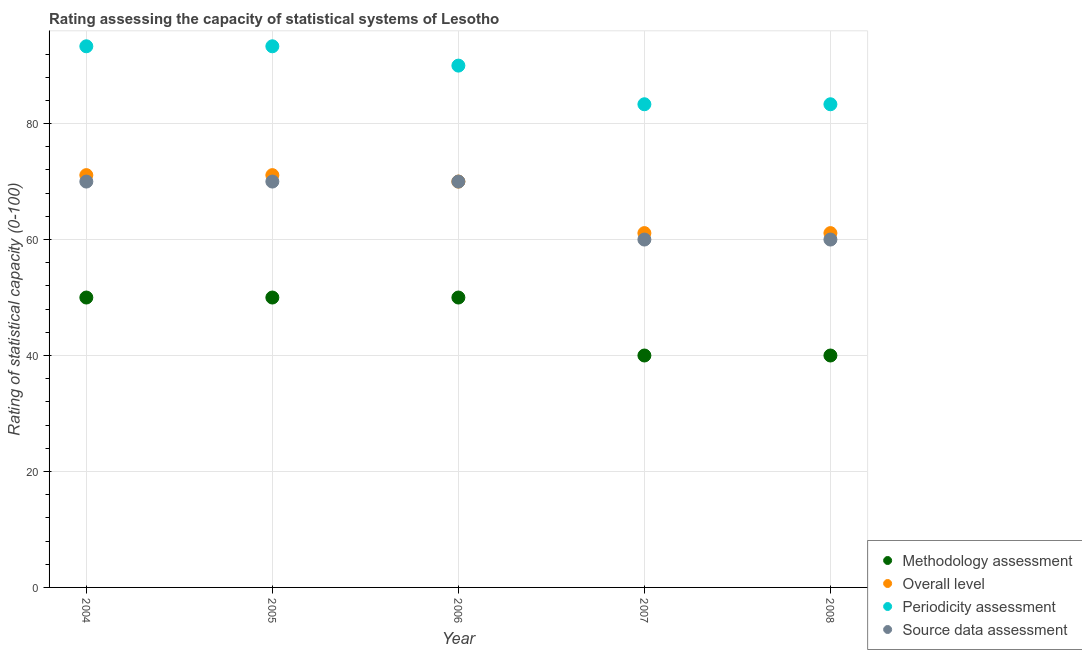Is the number of dotlines equal to the number of legend labels?
Provide a succinct answer. Yes. What is the source data assessment rating in 2008?
Your response must be concise. 60. Across all years, what is the maximum overall level rating?
Make the answer very short. 71.11. Across all years, what is the minimum source data assessment rating?
Your answer should be very brief. 60. In which year was the source data assessment rating maximum?
Make the answer very short. 2004. What is the total overall level rating in the graph?
Make the answer very short. 334.44. What is the difference between the periodicity assessment rating in 2004 and that in 2006?
Provide a short and direct response. 3.33. What is the difference between the methodology assessment rating in 2006 and the source data assessment rating in 2008?
Offer a terse response. -10. What is the average source data assessment rating per year?
Ensure brevity in your answer.  66. In the year 2006, what is the difference between the methodology assessment rating and source data assessment rating?
Ensure brevity in your answer.  -20. In how many years, is the periodicity assessment rating greater than 68?
Offer a very short reply. 5. What is the ratio of the overall level rating in 2005 to that in 2008?
Offer a very short reply. 1.16. What is the difference between the highest and the lowest methodology assessment rating?
Offer a very short reply. 10. Is the sum of the source data assessment rating in 2005 and 2008 greater than the maximum overall level rating across all years?
Your response must be concise. Yes. Is it the case that in every year, the sum of the methodology assessment rating and source data assessment rating is greater than the sum of periodicity assessment rating and overall level rating?
Your answer should be compact. No. Does the methodology assessment rating monotonically increase over the years?
Your answer should be compact. No. Is the overall level rating strictly greater than the methodology assessment rating over the years?
Give a very brief answer. Yes. Is the methodology assessment rating strictly less than the periodicity assessment rating over the years?
Offer a terse response. Yes. How many dotlines are there?
Provide a succinct answer. 4. How many legend labels are there?
Make the answer very short. 4. How are the legend labels stacked?
Your answer should be very brief. Vertical. What is the title of the graph?
Provide a succinct answer. Rating assessing the capacity of statistical systems of Lesotho. Does "Japan" appear as one of the legend labels in the graph?
Ensure brevity in your answer.  No. What is the label or title of the X-axis?
Your answer should be compact. Year. What is the label or title of the Y-axis?
Offer a terse response. Rating of statistical capacity (0-100). What is the Rating of statistical capacity (0-100) of Methodology assessment in 2004?
Keep it short and to the point. 50. What is the Rating of statistical capacity (0-100) in Overall level in 2004?
Your response must be concise. 71.11. What is the Rating of statistical capacity (0-100) of Periodicity assessment in 2004?
Provide a succinct answer. 93.33. What is the Rating of statistical capacity (0-100) in Overall level in 2005?
Your answer should be very brief. 71.11. What is the Rating of statistical capacity (0-100) in Periodicity assessment in 2005?
Your answer should be compact. 93.33. What is the Rating of statistical capacity (0-100) of Source data assessment in 2005?
Your answer should be very brief. 70. What is the Rating of statistical capacity (0-100) in Methodology assessment in 2006?
Give a very brief answer. 50. What is the Rating of statistical capacity (0-100) of Source data assessment in 2006?
Offer a terse response. 70. What is the Rating of statistical capacity (0-100) in Overall level in 2007?
Ensure brevity in your answer.  61.11. What is the Rating of statistical capacity (0-100) of Periodicity assessment in 2007?
Keep it short and to the point. 83.33. What is the Rating of statistical capacity (0-100) of Source data assessment in 2007?
Ensure brevity in your answer.  60. What is the Rating of statistical capacity (0-100) in Overall level in 2008?
Your response must be concise. 61.11. What is the Rating of statistical capacity (0-100) of Periodicity assessment in 2008?
Ensure brevity in your answer.  83.33. What is the Rating of statistical capacity (0-100) of Source data assessment in 2008?
Offer a very short reply. 60. Across all years, what is the maximum Rating of statistical capacity (0-100) of Methodology assessment?
Keep it short and to the point. 50. Across all years, what is the maximum Rating of statistical capacity (0-100) of Overall level?
Offer a terse response. 71.11. Across all years, what is the maximum Rating of statistical capacity (0-100) of Periodicity assessment?
Your answer should be very brief. 93.33. Across all years, what is the minimum Rating of statistical capacity (0-100) of Methodology assessment?
Offer a terse response. 40. Across all years, what is the minimum Rating of statistical capacity (0-100) of Overall level?
Keep it short and to the point. 61.11. Across all years, what is the minimum Rating of statistical capacity (0-100) of Periodicity assessment?
Provide a succinct answer. 83.33. Across all years, what is the minimum Rating of statistical capacity (0-100) in Source data assessment?
Provide a succinct answer. 60. What is the total Rating of statistical capacity (0-100) in Methodology assessment in the graph?
Offer a very short reply. 230. What is the total Rating of statistical capacity (0-100) in Overall level in the graph?
Provide a succinct answer. 334.44. What is the total Rating of statistical capacity (0-100) of Periodicity assessment in the graph?
Your answer should be compact. 443.33. What is the total Rating of statistical capacity (0-100) of Source data assessment in the graph?
Your answer should be very brief. 330. What is the difference between the Rating of statistical capacity (0-100) of Source data assessment in 2004 and that in 2005?
Offer a very short reply. 0. What is the difference between the Rating of statistical capacity (0-100) of Periodicity assessment in 2004 and that in 2006?
Ensure brevity in your answer.  3.33. What is the difference between the Rating of statistical capacity (0-100) in Methodology assessment in 2004 and that in 2008?
Your answer should be compact. 10. What is the difference between the Rating of statistical capacity (0-100) in Overall level in 2004 and that in 2008?
Keep it short and to the point. 10. What is the difference between the Rating of statistical capacity (0-100) of Methodology assessment in 2005 and that in 2006?
Provide a short and direct response. 0. What is the difference between the Rating of statistical capacity (0-100) in Periodicity assessment in 2005 and that in 2006?
Your answer should be very brief. 3.33. What is the difference between the Rating of statistical capacity (0-100) in Methodology assessment in 2005 and that in 2007?
Provide a short and direct response. 10. What is the difference between the Rating of statistical capacity (0-100) in Periodicity assessment in 2005 and that in 2007?
Offer a very short reply. 10. What is the difference between the Rating of statistical capacity (0-100) in Source data assessment in 2005 and that in 2007?
Give a very brief answer. 10. What is the difference between the Rating of statistical capacity (0-100) of Methodology assessment in 2005 and that in 2008?
Provide a succinct answer. 10. What is the difference between the Rating of statistical capacity (0-100) of Overall level in 2005 and that in 2008?
Give a very brief answer. 10. What is the difference between the Rating of statistical capacity (0-100) in Periodicity assessment in 2005 and that in 2008?
Offer a terse response. 10. What is the difference between the Rating of statistical capacity (0-100) of Methodology assessment in 2006 and that in 2007?
Your response must be concise. 10. What is the difference between the Rating of statistical capacity (0-100) in Overall level in 2006 and that in 2007?
Your answer should be compact. 8.89. What is the difference between the Rating of statistical capacity (0-100) of Source data assessment in 2006 and that in 2007?
Ensure brevity in your answer.  10. What is the difference between the Rating of statistical capacity (0-100) of Overall level in 2006 and that in 2008?
Ensure brevity in your answer.  8.89. What is the difference between the Rating of statistical capacity (0-100) of Periodicity assessment in 2006 and that in 2008?
Provide a short and direct response. 6.67. What is the difference between the Rating of statistical capacity (0-100) of Methodology assessment in 2007 and that in 2008?
Your response must be concise. 0. What is the difference between the Rating of statistical capacity (0-100) in Periodicity assessment in 2007 and that in 2008?
Make the answer very short. 0. What is the difference between the Rating of statistical capacity (0-100) of Methodology assessment in 2004 and the Rating of statistical capacity (0-100) of Overall level in 2005?
Ensure brevity in your answer.  -21.11. What is the difference between the Rating of statistical capacity (0-100) in Methodology assessment in 2004 and the Rating of statistical capacity (0-100) in Periodicity assessment in 2005?
Your answer should be compact. -43.33. What is the difference between the Rating of statistical capacity (0-100) in Overall level in 2004 and the Rating of statistical capacity (0-100) in Periodicity assessment in 2005?
Your response must be concise. -22.22. What is the difference between the Rating of statistical capacity (0-100) of Periodicity assessment in 2004 and the Rating of statistical capacity (0-100) of Source data assessment in 2005?
Offer a terse response. 23.33. What is the difference between the Rating of statistical capacity (0-100) in Methodology assessment in 2004 and the Rating of statistical capacity (0-100) in Overall level in 2006?
Ensure brevity in your answer.  -20. What is the difference between the Rating of statistical capacity (0-100) of Methodology assessment in 2004 and the Rating of statistical capacity (0-100) of Periodicity assessment in 2006?
Offer a very short reply. -40. What is the difference between the Rating of statistical capacity (0-100) in Overall level in 2004 and the Rating of statistical capacity (0-100) in Periodicity assessment in 2006?
Make the answer very short. -18.89. What is the difference between the Rating of statistical capacity (0-100) of Periodicity assessment in 2004 and the Rating of statistical capacity (0-100) of Source data assessment in 2006?
Your answer should be compact. 23.33. What is the difference between the Rating of statistical capacity (0-100) of Methodology assessment in 2004 and the Rating of statistical capacity (0-100) of Overall level in 2007?
Ensure brevity in your answer.  -11.11. What is the difference between the Rating of statistical capacity (0-100) of Methodology assessment in 2004 and the Rating of statistical capacity (0-100) of Periodicity assessment in 2007?
Your response must be concise. -33.33. What is the difference between the Rating of statistical capacity (0-100) in Methodology assessment in 2004 and the Rating of statistical capacity (0-100) in Source data assessment in 2007?
Keep it short and to the point. -10. What is the difference between the Rating of statistical capacity (0-100) of Overall level in 2004 and the Rating of statistical capacity (0-100) of Periodicity assessment in 2007?
Provide a short and direct response. -12.22. What is the difference between the Rating of statistical capacity (0-100) of Overall level in 2004 and the Rating of statistical capacity (0-100) of Source data assessment in 2007?
Ensure brevity in your answer.  11.11. What is the difference between the Rating of statistical capacity (0-100) in Periodicity assessment in 2004 and the Rating of statistical capacity (0-100) in Source data assessment in 2007?
Ensure brevity in your answer.  33.33. What is the difference between the Rating of statistical capacity (0-100) of Methodology assessment in 2004 and the Rating of statistical capacity (0-100) of Overall level in 2008?
Your answer should be very brief. -11.11. What is the difference between the Rating of statistical capacity (0-100) in Methodology assessment in 2004 and the Rating of statistical capacity (0-100) in Periodicity assessment in 2008?
Provide a succinct answer. -33.33. What is the difference between the Rating of statistical capacity (0-100) of Overall level in 2004 and the Rating of statistical capacity (0-100) of Periodicity assessment in 2008?
Offer a very short reply. -12.22. What is the difference between the Rating of statistical capacity (0-100) of Overall level in 2004 and the Rating of statistical capacity (0-100) of Source data assessment in 2008?
Your response must be concise. 11.11. What is the difference between the Rating of statistical capacity (0-100) of Periodicity assessment in 2004 and the Rating of statistical capacity (0-100) of Source data assessment in 2008?
Your answer should be very brief. 33.33. What is the difference between the Rating of statistical capacity (0-100) in Methodology assessment in 2005 and the Rating of statistical capacity (0-100) in Periodicity assessment in 2006?
Provide a succinct answer. -40. What is the difference between the Rating of statistical capacity (0-100) of Overall level in 2005 and the Rating of statistical capacity (0-100) of Periodicity assessment in 2006?
Offer a terse response. -18.89. What is the difference between the Rating of statistical capacity (0-100) of Overall level in 2005 and the Rating of statistical capacity (0-100) of Source data assessment in 2006?
Your response must be concise. 1.11. What is the difference between the Rating of statistical capacity (0-100) in Periodicity assessment in 2005 and the Rating of statistical capacity (0-100) in Source data assessment in 2006?
Offer a terse response. 23.33. What is the difference between the Rating of statistical capacity (0-100) of Methodology assessment in 2005 and the Rating of statistical capacity (0-100) of Overall level in 2007?
Make the answer very short. -11.11. What is the difference between the Rating of statistical capacity (0-100) of Methodology assessment in 2005 and the Rating of statistical capacity (0-100) of Periodicity assessment in 2007?
Your response must be concise. -33.33. What is the difference between the Rating of statistical capacity (0-100) of Overall level in 2005 and the Rating of statistical capacity (0-100) of Periodicity assessment in 2007?
Ensure brevity in your answer.  -12.22. What is the difference between the Rating of statistical capacity (0-100) in Overall level in 2005 and the Rating of statistical capacity (0-100) in Source data assessment in 2007?
Offer a terse response. 11.11. What is the difference between the Rating of statistical capacity (0-100) in Periodicity assessment in 2005 and the Rating of statistical capacity (0-100) in Source data assessment in 2007?
Offer a very short reply. 33.33. What is the difference between the Rating of statistical capacity (0-100) in Methodology assessment in 2005 and the Rating of statistical capacity (0-100) in Overall level in 2008?
Provide a short and direct response. -11.11. What is the difference between the Rating of statistical capacity (0-100) in Methodology assessment in 2005 and the Rating of statistical capacity (0-100) in Periodicity assessment in 2008?
Offer a very short reply. -33.33. What is the difference between the Rating of statistical capacity (0-100) of Methodology assessment in 2005 and the Rating of statistical capacity (0-100) of Source data assessment in 2008?
Ensure brevity in your answer.  -10. What is the difference between the Rating of statistical capacity (0-100) in Overall level in 2005 and the Rating of statistical capacity (0-100) in Periodicity assessment in 2008?
Your response must be concise. -12.22. What is the difference between the Rating of statistical capacity (0-100) in Overall level in 2005 and the Rating of statistical capacity (0-100) in Source data assessment in 2008?
Make the answer very short. 11.11. What is the difference between the Rating of statistical capacity (0-100) of Periodicity assessment in 2005 and the Rating of statistical capacity (0-100) of Source data assessment in 2008?
Offer a very short reply. 33.33. What is the difference between the Rating of statistical capacity (0-100) in Methodology assessment in 2006 and the Rating of statistical capacity (0-100) in Overall level in 2007?
Provide a short and direct response. -11.11. What is the difference between the Rating of statistical capacity (0-100) in Methodology assessment in 2006 and the Rating of statistical capacity (0-100) in Periodicity assessment in 2007?
Make the answer very short. -33.33. What is the difference between the Rating of statistical capacity (0-100) in Methodology assessment in 2006 and the Rating of statistical capacity (0-100) in Source data assessment in 2007?
Your answer should be very brief. -10. What is the difference between the Rating of statistical capacity (0-100) in Overall level in 2006 and the Rating of statistical capacity (0-100) in Periodicity assessment in 2007?
Give a very brief answer. -13.33. What is the difference between the Rating of statistical capacity (0-100) in Overall level in 2006 and the Rating of statistical capacity (0-100) in Source data assessment in 2007?
Ensure brevity in your answer.  10. What is the difference between the Rating of statistical capacity (0-100) of Periodicity assessment in 2006 and the Rating of statistical capacity (0-100) of Source data assessment in 2007?
Keep it short and to the point. 30. What is the difference between the Rating of statistical capacity (0-100) of Methodology assessment in 2006 and the Rating of statistical capacity (0-100) of Overall level in 2008?
Make the answer very short. -11.11. What is the difference between the Rating of statistical capacity (0-100) of Methodology assessment in 2006 and the Rating of statistical capacity (0-100) of Periodicity assessment in 2008?
Your answer should be compact. -33.33. What is the difference between the Rating of statistical capacity (0-100) in Methodology assessment in 2006 and the Rating of statistical capacity (0-100) in Source data assessment in 2008?
Your answer should be compact. -10. What is the difference between the Rating of statistical capacity (0-100) in Overall level in 2006 and the Rating of statistical capacity (0-100) in Periodicity assessment in 2008?
Provide a succinct answer. -13.33. What is the difference between the Rating of statistical capacity (0-100) in Overall level in 2006 and the Rating of statistical capacity (0-100) in Source data assessment in 2008?
Provide a short and direct response. 10. What is the difference between the Rating of statistical capacity (0-100) of Methodology assessment in 2007 and the Rating of statistical capacity (0-100) of Overall level in 2008?
Your answer should be compact. -21.11. What is the difference between the Rating of statistical capacity (0-100) in Methodology assessment in 2007 and the Rating of statistical capacity (0-100) in Periodicity assessment in 2008?
Your answer should be very brief. -43.33. What is the difference between the Rating of statistical capacity (0-100) of Overall level in 2007 and the Rating of statistical capacity (0-100) of Periodicity assessment in 2008?
Offer a very short reply. -22.22. What is the difference between the Rating of statistical capacity (0-100) in Overall level in 2007 and the Rating of statistical capacity (0-100) in Source data assessment in 2008?
Ensure brevity in your answer.  1.11. What is the difference between the Rating of statistical capacity (0-100) in Periodicity assessment in 2007 and the Rating of statistical capacity (0-100) in Source data assessment in 2008?
Ensure brevity in your answer.  23.33. What is the average Rating of statistical capacity (0-100) in Overall level per year?
Your answer should be very brief. 66.89. What is the average Rating of statistical capacity (0-100) in Periodicity assessment per year?
Keep it short and to the point. 88.67. What is the average Rating of statistical capacity (0-100) of Source data assessment per year?
Offer a very short reply. 66. In the year 2004, what is the difference between the Rating of statistical capacity (0-100) in Methodology assessment and Rating of statistical capacity (0-100) in Overall level?
Keep it short and to the point. -21.11. In the year 2004, what is the difference between the Rating of statistical capacity (0-100) of Methodology assessment and Rating of statistical capacity (0-100) of Periodicity assessment?
Your answer should be compact. -43.33. In the year 2004, what is the difference between the Rating of statistical capacity (0-100) of Methodology assessment and Rating of statistical capacity (0-100) of Source data assessment?
Give a very brief answer. -20. In the year 2004, what is the difference between the Rating of statistical capacity (0-100) in Overall level and Rating of statistical capacity (0-100) in Periodicity assessment?
Make the answer very short. -22.22. In the year 2004, what is the difference between the Rating of statistical capacity (0-100) of Overall level and Rating of statistical capacity (0-100) of Source data assessment?
Give a very brief answer. 1.11. In the year 2004, what is the difference between the Rating of statistical capacity (0-100) of Periodicity assessment and Rating of statistical capacity (0-100) of Source data assessment?
Provide a short and direct response. 23.33. In the year 2005, what is the difference between the Rating of statistical capacity (0-100) in Methodology assessment and Rating of statistical capacity (0-100) in Overall level?
Your answer should be very brief. -21.11. In the year 2005, what is the difference between the Rating of statistical capacity (0-100) in Methodology assessment and Rating of statistical capacity (0-100) in Periodicity assessment?
Keep it short and to the point. -43.33. In the year 2005, what is the difference between the Rating of statistical capacity (0-100) of Methodology assessment and Rating of statistical capacity (0-100) of Source data assessment?
Your answer should be very brief. -20. In the year 2005, what is the difference between the Rating of statistical capacity (0-100) in Overall level and Rating of statistical capacity (0-100) in Periodicity assessment?
Offer a very short reply. -22.22. In the year 2005, what is the difference between the Rating of statistical capacity (0-100) in Periodicity assessment and Rating of statistical capacity (0-100) in Source data assessment?
Provide a succinct answer. 23.33. In the year 2006, what is the difference between the Rating of statistical capacity (0-100) of Methodology assessment and Rating of statistical capacity (0-100) of Periodicity assessment?
Your answer should be compact. -40. In the year 2006, what is the difference between the Rating of statistical capacity (0-100) of Periodicity assessment and Rating of statistical capacity (0-100) of Source data assessment?
Give a very brief answer. 20. In the year 2007, what is the difference between the Rating of statistical capacity (0-100) of Methodology assessment and Rating of statistical capacity (0-100) of Overall level?
Ensure brevity in your answer.  -21.11. In the year 2007, what is the difference between the Rating of statistical capacity (0-100) of Methodology assessment and Rating of statistical capacity (0-100) of Periodicity assessment?
Provide a succinct answer. -43.33. In the year 2007, what is the difference between the Rating of statistical capacity (0-100) in Methodology assessment and Rating of statistical capacity (0-100) in Source data assessment?
Give a very brief answer. -20. In the year 2007, what is the difference between the Rating of statistical capacity (0-100) of Overall level and Rating of statistical capacity (0-100) of Periodicity assessment?
Provide a succinct answer. -22.22. In the year 2007, what is the difference between the Rating of statistical capacity (0-100) of Periodicity assessment and Rating of statistical capacity (0-100) of Source data assessment?
Provide a succinct answer. 23.33. In the year 2008, what is the difference between the Rating of statistical capacity (0-100) of Methodology assessment and Rating of statistical capacity (0-100) of Overall level?
Offer a very short reply. -21.11. In the year 2008, what is the difference between the Rating of statistical capacity (0-100) in Methodology assessment and Rating of statistical capacity (0-100) in Periodicity assessment?
Give a very brief answer. -43.33. In the year 2008, what is the difference between the Rating of statistical capacity (0-100) in Overall level and Rating of statistical capacity (0-100) in Periodicity assessment?
Provide a short and direct response. -22.22. In the year 2008, what is the difference between the Rating of statistical capacity (0-100) of Periodicity assessment and Rating of statistical capacity (0-100) of Source data assessment?
Make the answer very short. 23.33. What is the ratio of the Rating of statistical capacity (0-100) of Overall level in 2004 to that in 2006?
Your answer should be very brief. 1.02. What is the ratio of the Rating of statistical capacity (0-100) in Source data assessment in 2004 to that in 2006?
Provide a succinct answer. 1. What is the ratio of the Rating of statistical capacity (0-100) of Overall level in 2004 to that in 2007?
Provide a short and direct response. 1.16. What is the ratio of the Rating of statistical capacity (0-100) in Periodicity assessment in 2004 to that in 2007?
Provide a succinct answer. 1.12. What is the ratio of the Rating of statistical capacity (0-100) in Overall level in 2004 to that in 2008?
Provide a succinct answer. 1.16. What is the ratio of the Rating of statistical capacity (0-100) in Periodicity assessment in 2004 to that in 2008?
Your response must be concise. 1.12. What is the ratio of the Rating of statistical capacity (0-100) of Source data assessment in 2004 to that in 2008?
Make the answer very short. 1.17. What is the ratio of the Rating of statistical capacity (0-100) of Methodology assessment in 2005 to that in 2006?
Provide a succinct answer. 1. What is the ratio of the Rating of statistical capacity (0-100) in Overall level in 2005 to that in 2006?
Provide a short and direct response. 1.02. What is the ratio of the Rating of statistical capacity (0-100) of Periodicity assessment in 2005 to that in 2006?
Provide a short and direct response. 1.04. What is the ratio of the Rating of statistical capacity (0-100) in Methodology assessment in 2005 to that in 2007?
Make the answer very short. 1.25. What is the ratio of the Rating of statistical capacity (0-100) of Overall level in 2005 to that in 2007?
Offer a very short reply. 1.16. What is the ratio of the Rating of statistical capacity (0-100) in Periodicity assessment in 2005 to that in 2007?
Provide a short and direct response. 1.12. What is the ratio of the Rating of statistical capacity (0-100) in Source data assessment in 2005 to that in 2007?
Make the answer very short. 1.17. What is the ratio of the Rating of statistical capacity (0-100) in Overall level in 2005 to that in 2008?
Your response must be concise. 1.16. What is the ratio of the Rating of statistical capacity (0-100) of Periodicity assessment in 2005 to that in 2008?
Make the answer very short. 1.12. What is the ratio of the Rating of statistical capacity (0-100) of Source data assessment in 2005 to that in 2008?
Ensure brevity in your answer.  1.17. What is the ratio of the Rating of statistical capacity (0-100) in Methodology assessment in 2006 to that in 2007?
Your answer should be compact. 1.25. What is the ratio of the Rating of statistical capacity (0-100) of Overall level in 2006 to that in 2007?
Ensure brevity in your answer.  1.15. What is the ratio of the Rating of statistical capacity (0-100) of Overall level in 2006 to that in 2008?
Give a very brief answer. 1.15. What is the ratio of the Rating of statistical capacity (0-100) of Source data assessment in 2006 to that in 2008?
Offer a very short reply. 1.17. What is the ratio of the Rating of statistical capacity (0-100) in Periodicity assessment in 2007 to that in 2008?
Offer a terse response. 1. What is the difference between the highest and the second highest Rating of statistical capacity (0-100) in Methodology assessment?
Keep it short and to the point. 0. What is the difference between the highest and the second highest Rating of statistical capacity (0-100) in Overall level?
Ensure brevity in your answer.  0. What is the difference between the highest and the lowest Rating of statistical capacity (0-100) of Periodicity assessment?
Your response must be concise. 10. What is the difference between the highest and the lowest Rating of statistical capacity (0-100) in Source data assessment?
Your answer should be compact. 10. 